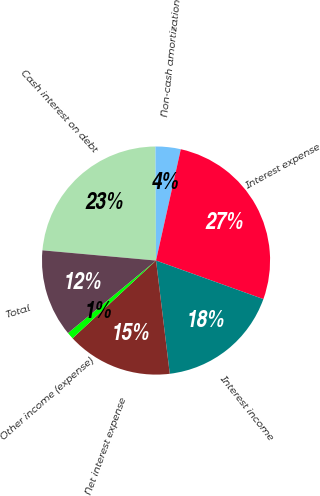Convert chart. <chart><loc_0><loc_0><loc_500><loc_500><pie_chart><fcel>Cash interest on debt<fcel>Non-cash amortization<fcel>Interest expense<fcel>Interest income<fcel>Net interest expense<fcel>Other income (expense)<fcel>Total<nl><fcel>23.49%<fcel>3.57%<fcel>27.0%<fcel>17.59%<fcel>14.99%<fcel>0.97%<fcel>12.39%<nl></chart> 